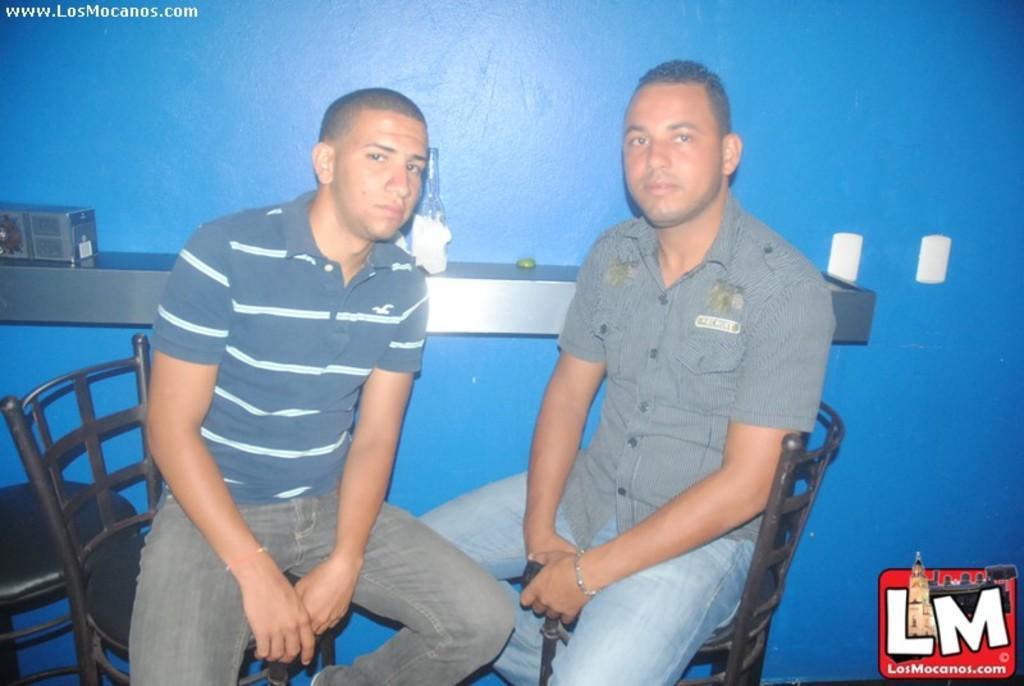Could you give a brief overview of what you see in this image? This image consists of two men sitting in a chair. In the background, there is a wall in blue color on which there is a rack fixed along with a bottle. 